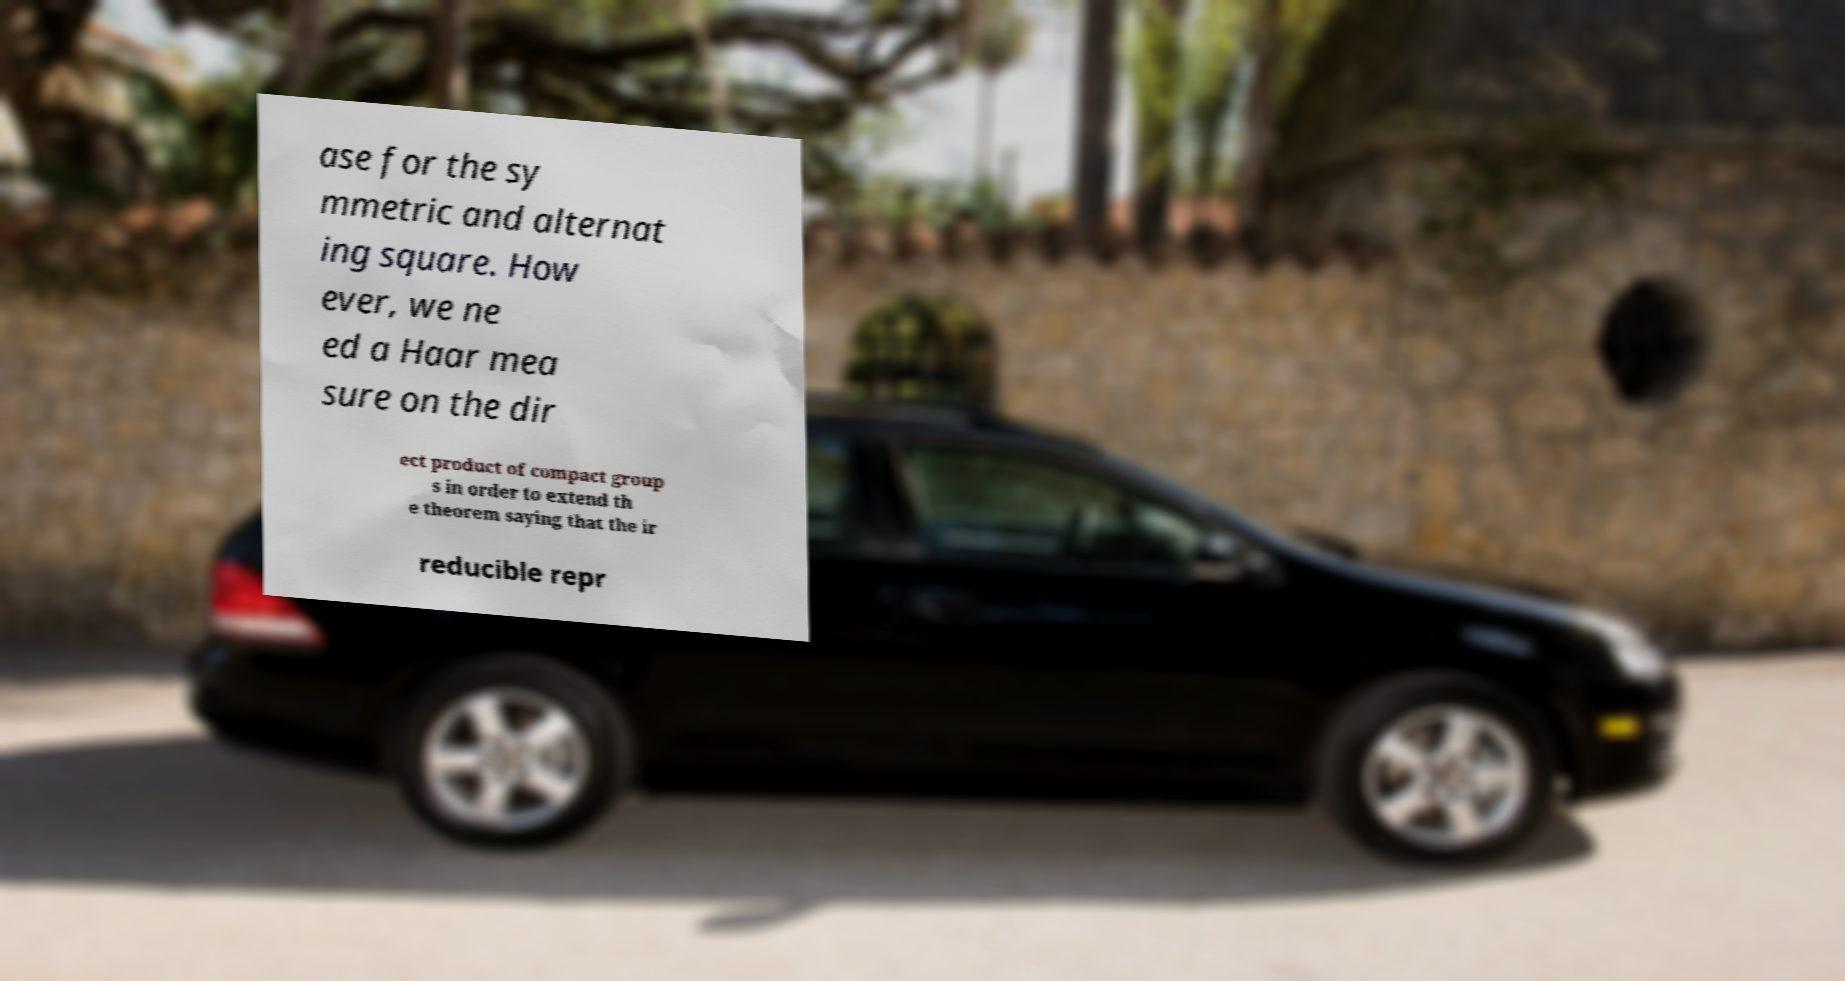Can you read and provide the text displayed in the image?This photo seems to have some interesting text. Can you extract and type it out for me? ase for the sy mmetric and alternat ing square. How ever, we ne ed a Haar mea sure on the dir ect product of compact group s in order to extend th e theorem saying that the ir reducible repr 